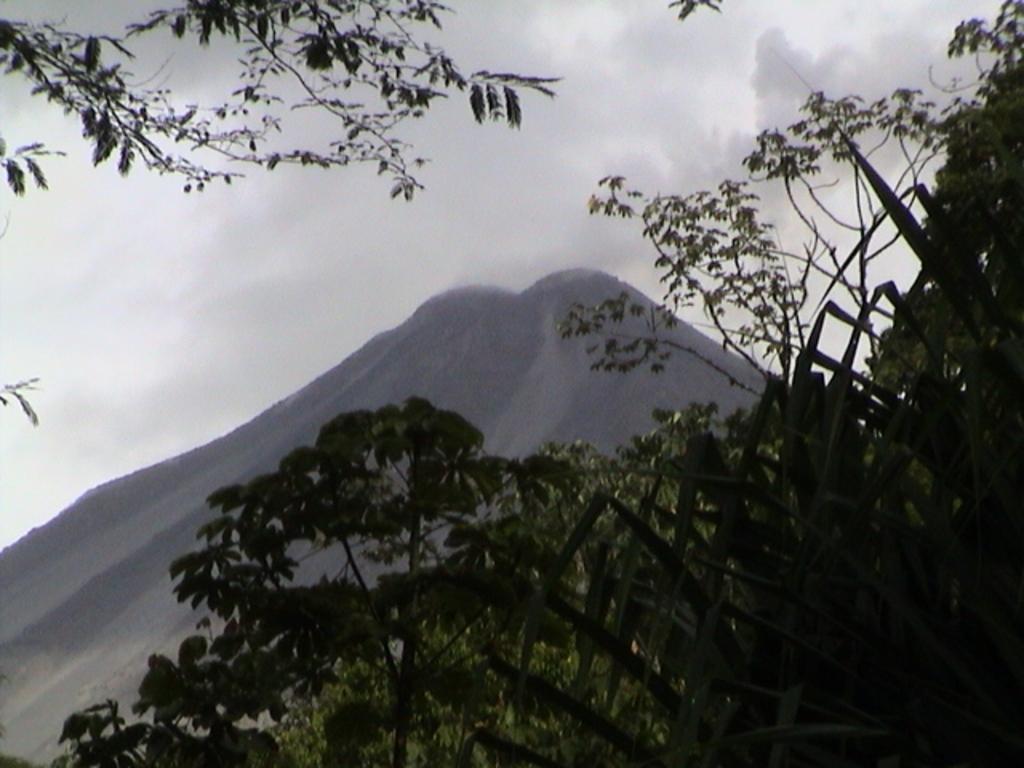In one or two sentences, can you explain what this image depicts? At the bottom we can see plants and trees. On the left side at the top corner there is a tree. In the background we can see a mountain and clouds in the sky. 